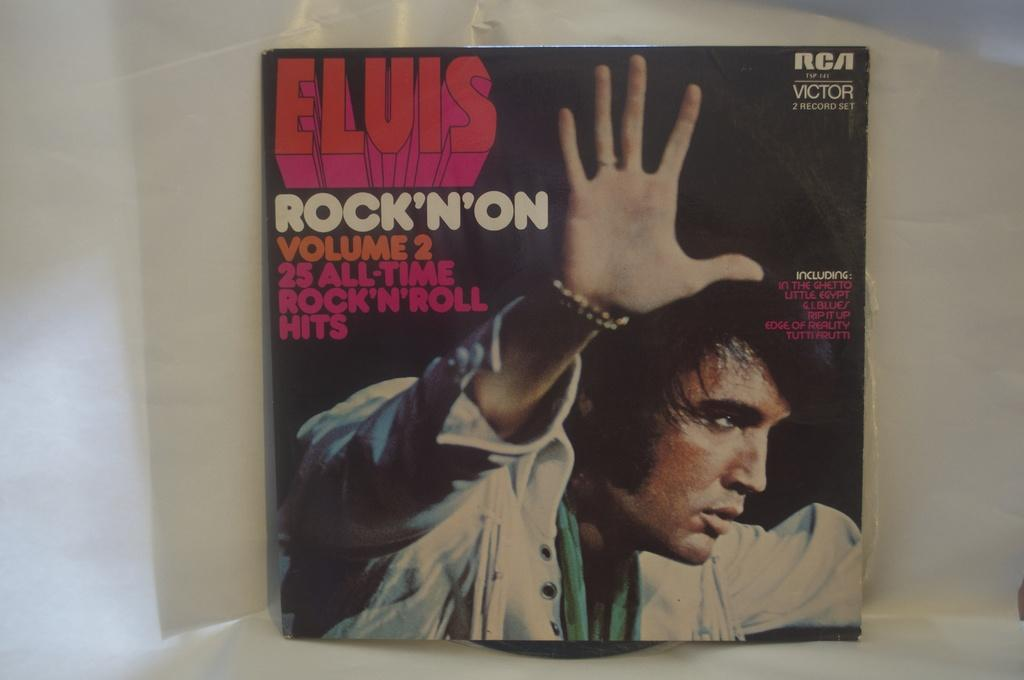<image>
Describe the image concisely. An album cover of Elvis Rock'N'On Volume 2. 